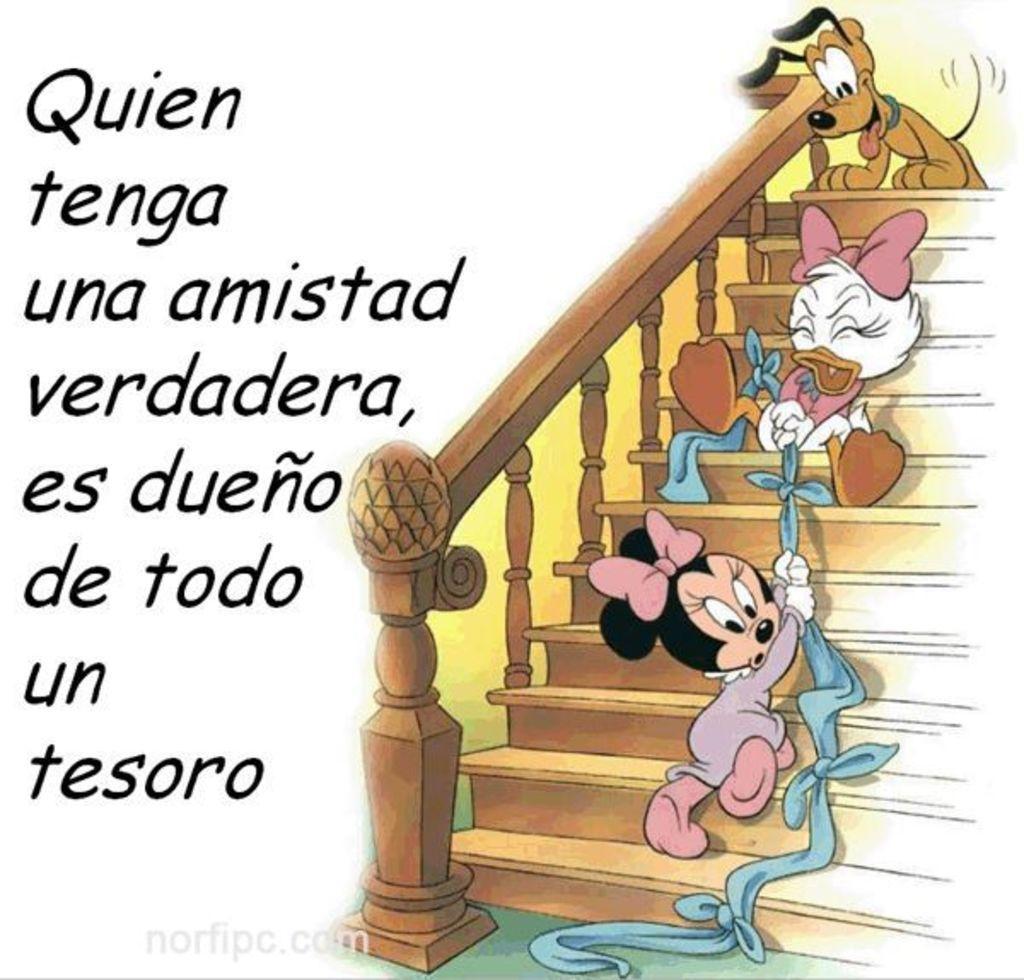Please provide a concise description of this image. In this image, we can see cartoons on stairs and some text. 